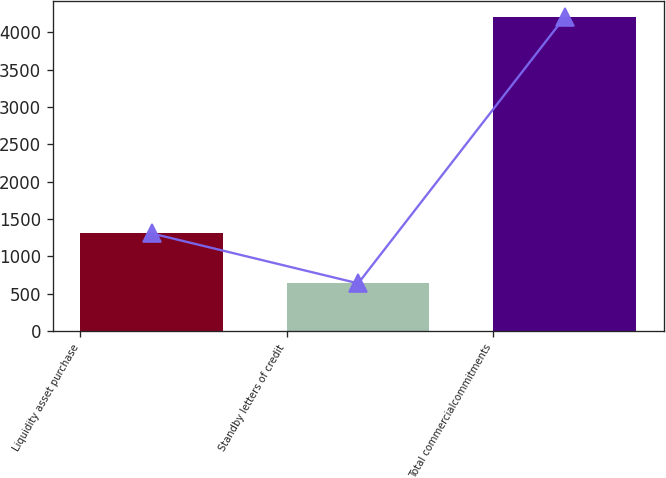<chart> <loc_0><loc_0><loc_500><loc_500><bar_chart><fcel>Liquidity asset purchase<fcel>Standby letters of credit<fcel>Total commercialcommitments<nl><fcel>1309<fcel>640<fcel>4205<nl></chart> 